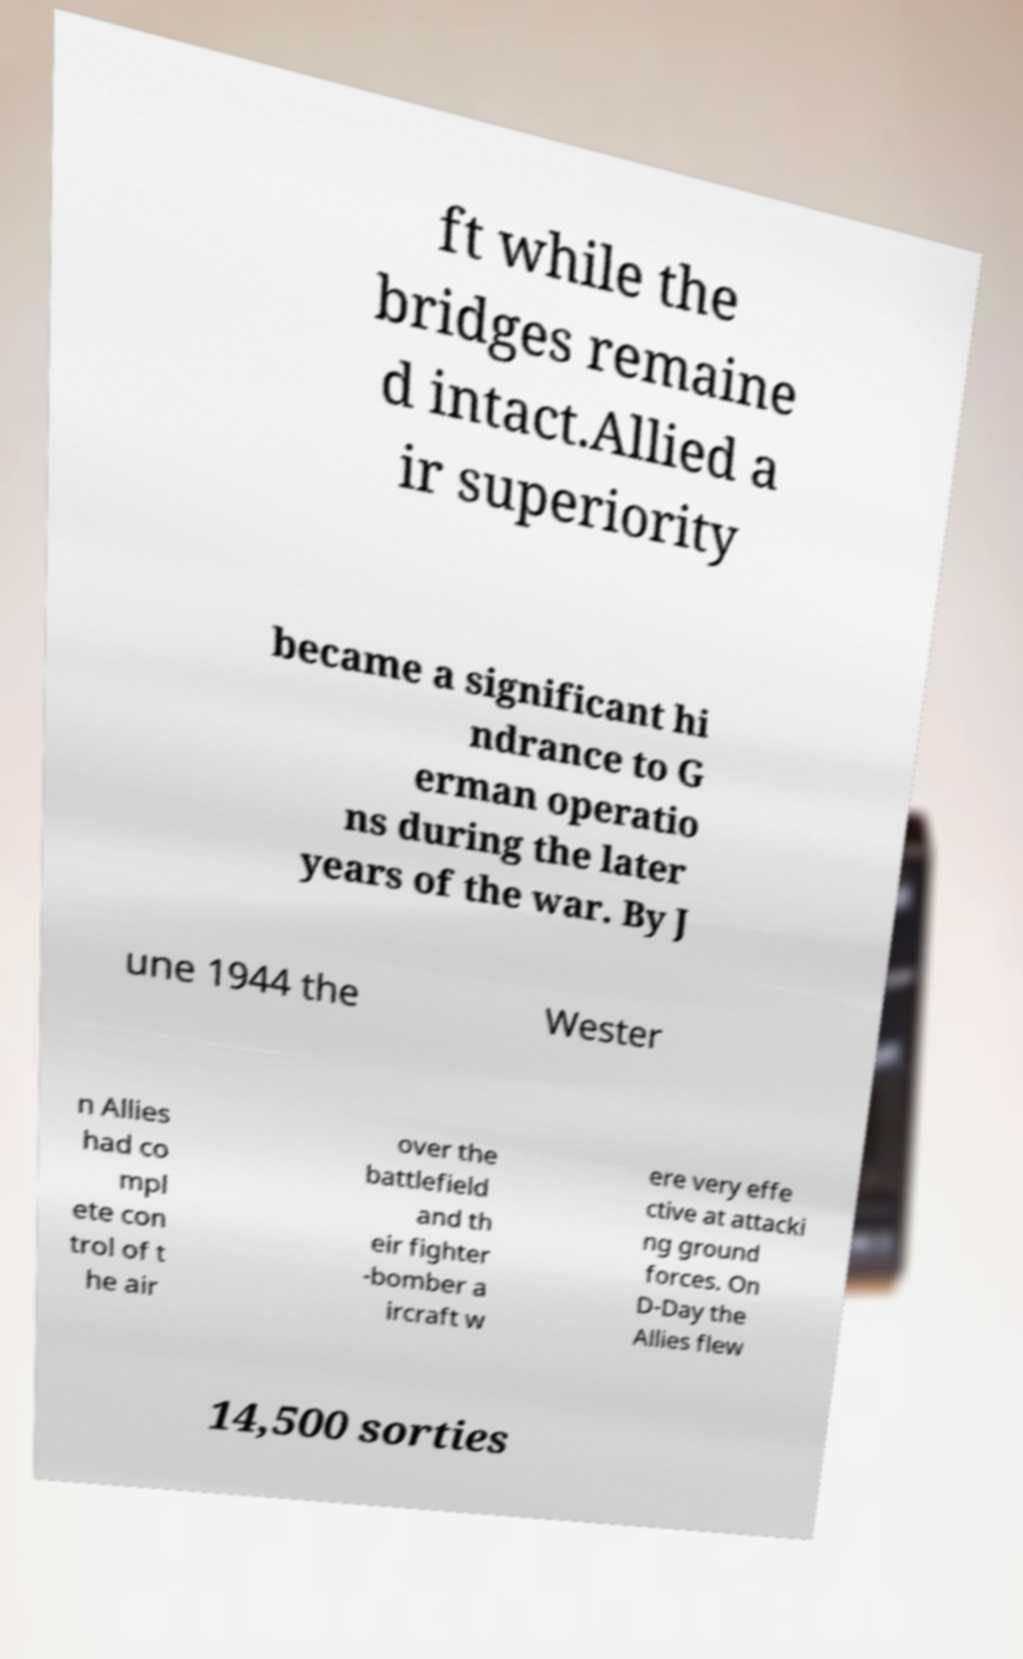There's text embedded in this image that I need extracted. Can you transcribe it verbatim? ft while the bridges remaine d intact.Allied a ir superiority became a significant hi ndrance to G erman operatio ns during the later years of the war. By J une 1944 the Wester n Allies had co mpl ete con trol of t he air over the battlefield and th eir fighter -bomber a ircraft w ere very effe ctive at attacki ng ground forces. On D-Day the Allies flew 14,500 sorties 